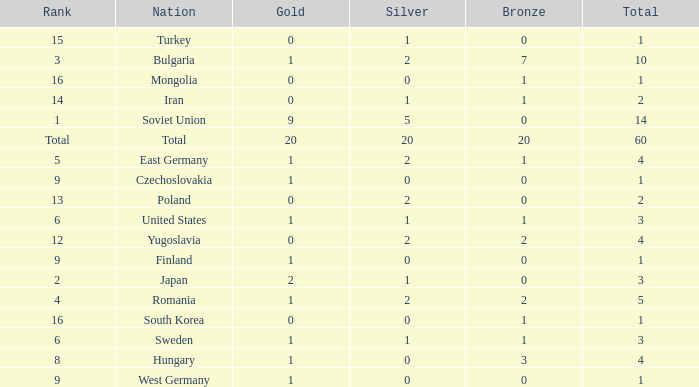What is the number of totals that have silvers under 2, bronzes over 0, and golds over 1? 0.0. 